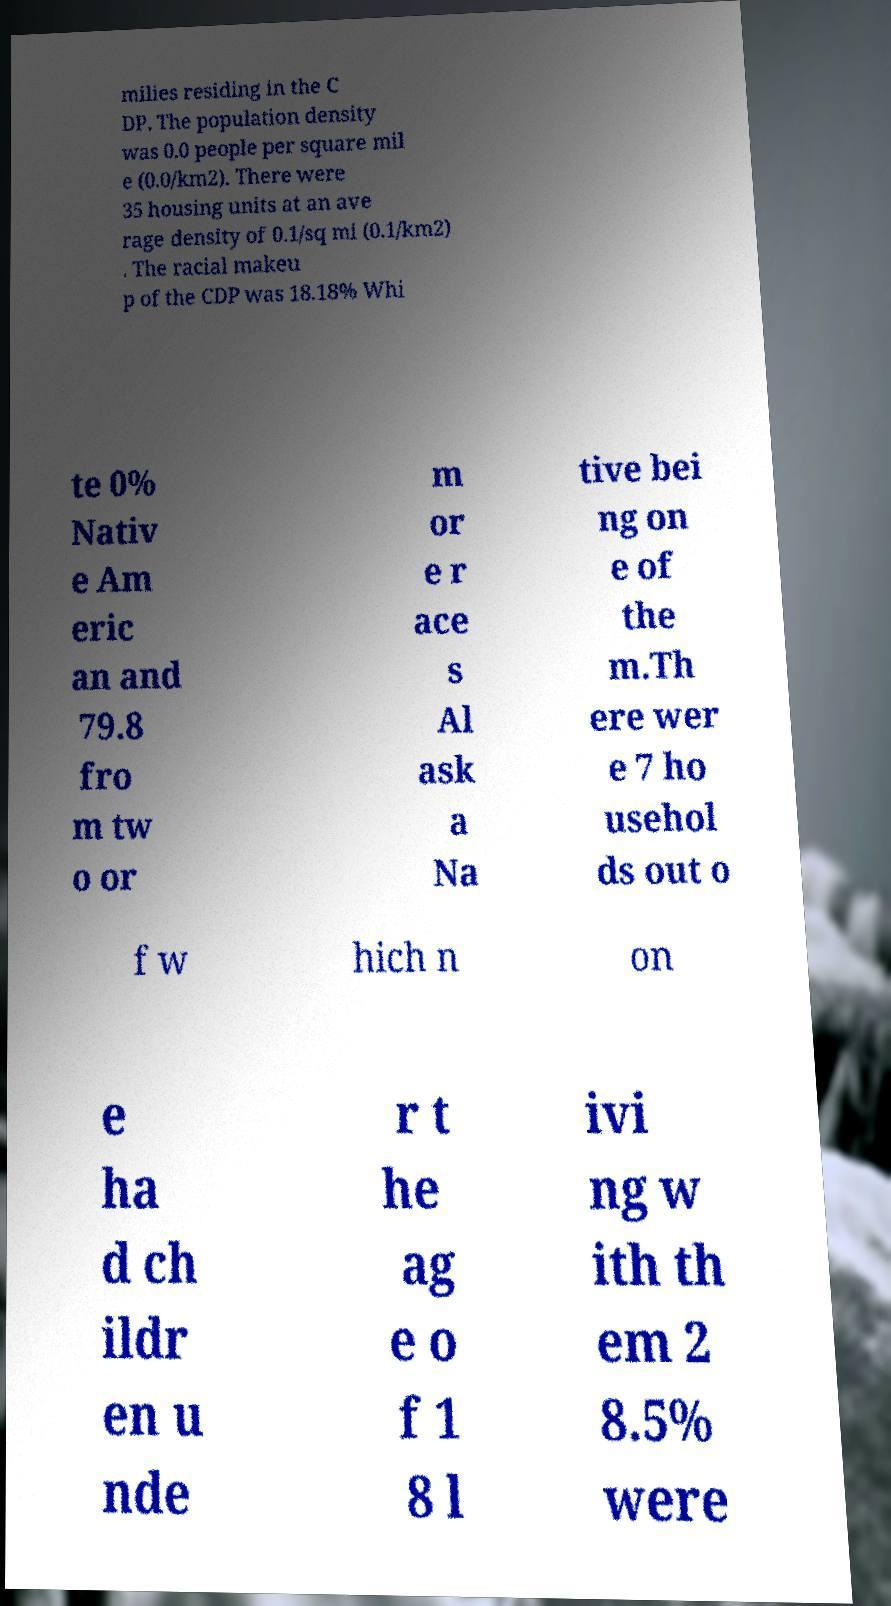For documentation purposes, I need the text within this image transcribed. Could you provide that? milies residing in the C DP. The population density was 0.0 people per square mil e (0.0/km2). There were 35 housing units at an ave rage density of 0.1/sq mi (0.1/km2) . The racial makeu p of the CDP was 18.18% Whi te 0% Nativ e Am eric an and 79.8 fro m tw o or m or e r ace s Al ask a Na tive bei ng on e of the m.Th ere wer e 7 ho usehol ds out o f w hich n on e ha d ch ildr en u nde r t he ag e o f 1 8 l ivi ng w ith th em 2 8.5% were 